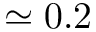<formula> <loc_0><loc_0><loc_500><loc_500>\simeq 0 . 2</formula> 